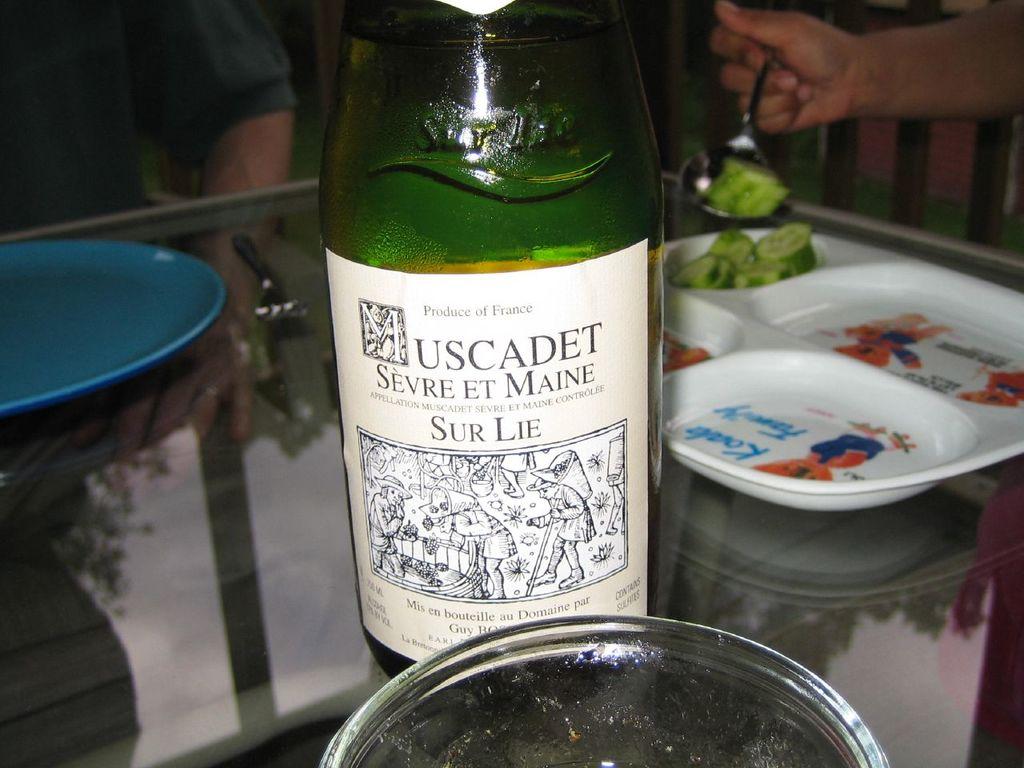Which nation is the bottled drink made in?
Provide a short and direct response. France. 